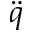<formula> <loc_0><loc_0><loc_500><loc_500>\ddot { q }</formula> 